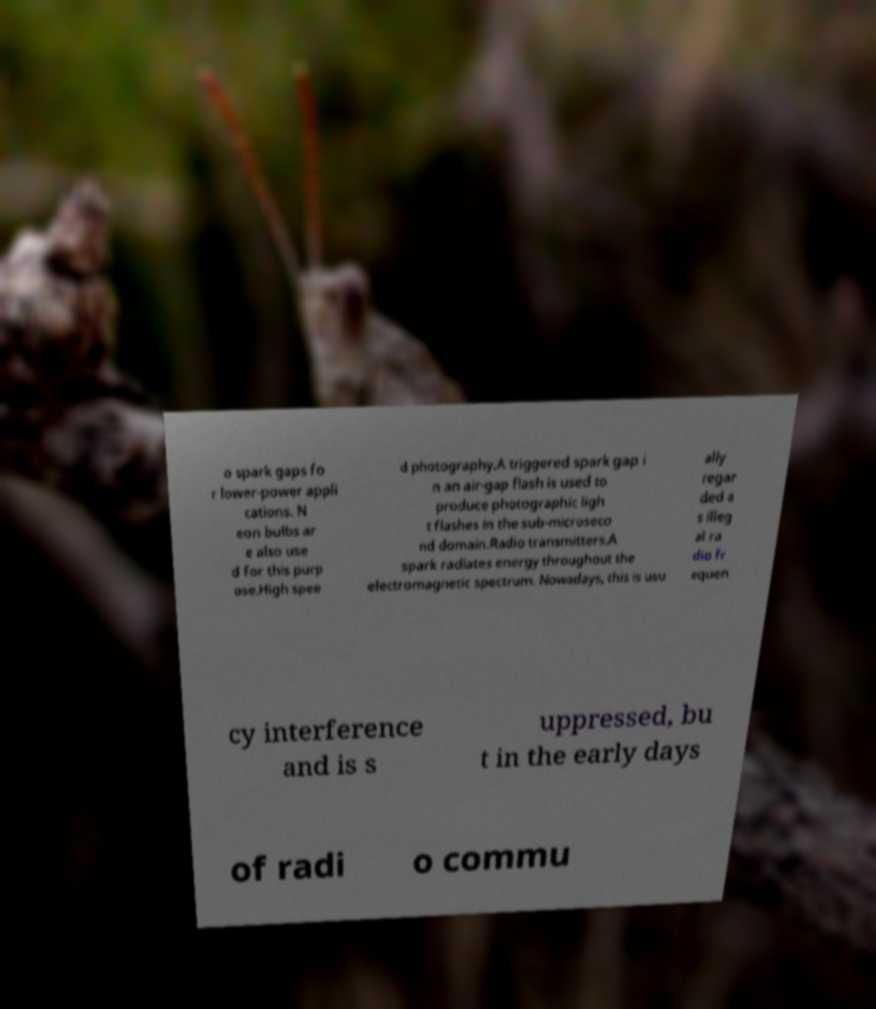I need the written content from this picture converted into text. Can you do that? o spark gaps fo r lower-power appli cations. N eon bulbs ar e also use d for this purp ose.High spee d photography.A triggered spark gap i n an air-gap flash is used to produce photographic ligh t flashes in the sub-microseco nd domain.Radio transmitters.A spark radiates energy throughout the electromagnetic spectrum. Nowadays, this is usu ally regar ded a s illeg al ra dio fr equen cy interference and is s uppressed, bu t in the early days of radi o commu 